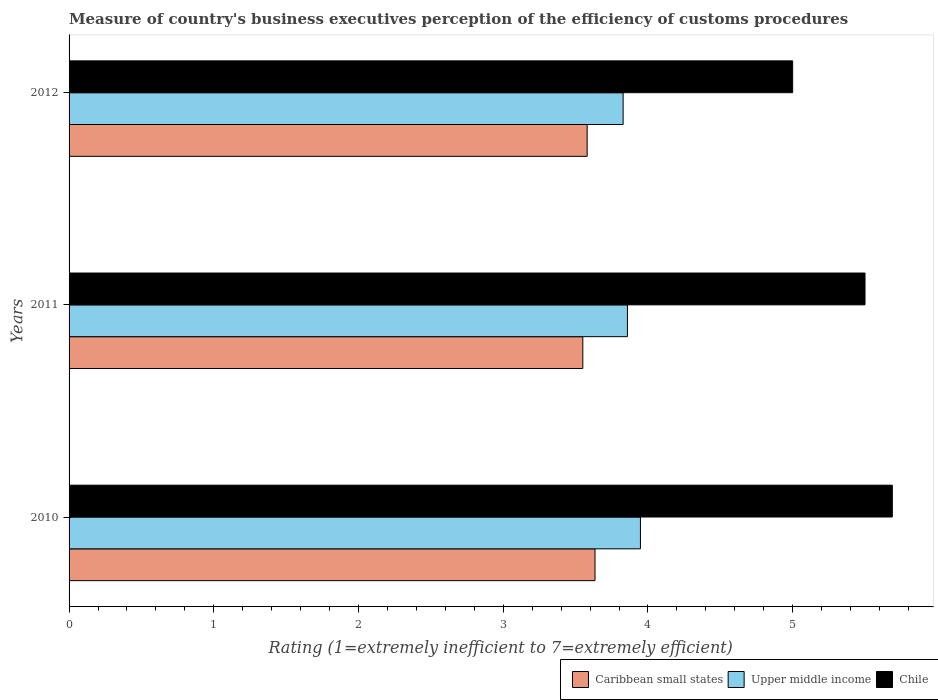Are the number of bars per tick equal to the number of legend labels?
Your answer should be compact. Yes. Are the number of bars on each tick of the Y-axis equal?
Your answer should be very brief. Yes. How many bars are there on the 1st tick from the bottom?
Offer a terse response. 3. Across all years, what is the maximum rating of the efficiency of customs procedure in Chile?
Ensure brevity in your answer.  5.69. Across all years, what is the minimum rating of the efficiency of customs procedure in Upper middle income?
Make the answer very short. 3.83. In which year was the rating of the efficiency of customs procedure in Chile maximum?
Provide a succinct answer. 2010. In which year was the rating of the efficiency of customs procedure in Upper middle income minimum?
Provide a succinct answer. 2012. What is the total rating of the efficiency of customs procedure in Caribbean small states in the graph?
Make the answer very short. 10.76. What is the difference between the rating of the efficiency of customs procedure in Chile in 2010 and that in 2012?
Make the answer very short. 0.69. What is the difference between the rating of the efficiency of customs procedure in Upper middle income in 2010 and the rating of the efficiency of customs procedure in Chile in 2011?
Provide a short and direct response. -1.55. What is the average rating of the efficiency of customs procedure in Upper middle income per year?
Offer a very short reply. 3.88. In the year 2011, what is the difference between the rating of the efficiency of customs procedure in Upper middle income and rating of the efficiency of customs procedure in Caribbean small states?
Give a very brief answer. 0.31. What is the ratio of the rating of the efficiency of customs procedure in Caribbean small states in 2011 to that in 2012?
Your answer should be very brief. 0.99. What is the difference between the highest and the second highest rating of the efficiency of customs procedure in Caribbean small states?
Offer a very short reply. 0.05. What is the difference between the highest and the lowest rating of the efficiency of customs procedure in Chile?
Offer a terse response. 0.69. What does the 2nd bar from the top in 2012 represents?
Your answer should be very brief. Upper middle income. Is it the case that in every year, the sum of the rating of the efficiency of customs procedure in Chile and rating of the efficiency of customs procedure in Caribbean small states is greater than the rating of the efficiency of customs procedure in Upper middle income?
Provide a short and direct response. Yes. How many bars are there?
Keep it short and to the point. 9. Are all the bars in the graph horizontal?
Keep it short and to the point. Yes. How many years are there in the graph?
Make the answer very short. 3. How many legend labels are there?
Offer a very short reply. 3. What is the title of the graph?
Keep it short and to the point. Measure of country's business executives perception of the efficiency of customs procedures. Does "Kyrgyz Republic" appear as one of the legend labels in the graph?
Your answer should be compact. No. What is the label or title of the X-axis?
Ensure brevity in your answer.  Rating (1=extremely inefficient to 7=extremely efficient). What is the label or title of the Y-axis?
Give a very brief answer. Years. What is the Rating (1=extremely inefficient to 7=extremely efficient) in Caribbean small states in 2010?
Offer a very short reply. 3.63. What is the Rating (1=extremely inefficient to 7=extremely efficient) in Upper middle income in 2010?
Keep it short and to the point. 3.95. What is the Rating (1=extremely inefficient to 7=extremely efficient) of Chile in 2010?
Keep it short and to the point. 5.69. What is the Rating (1=extremely inefficient to 7=extremely efficient) of Caribbean small states in 2011?
Provide a succinct answer. 3.55. What is the Rating (1=extremely inefficient to 7=extremely efficient) in Upper middle income in 2011?
Keep it short and to the point. 3.86. What is the Rating (1=extremely inefficient to 7=extremely efficient) of Chile in 2011?
Ensure brevity in your answer.  5.5. What is the Rating (1=extremely inefficient to 7=extremely efficient) in Caribbean small states in 2012?
Provide a short and direct response. 3.58. What is the Rating (1=extremely inefficient to 7=extremely efficient) of Upper middle income in 2012?
Offer a very short reply. 3.83. Across all years, what is the maximum Rating (1=extremely inefficient to 7=extremely efficient) in Caribbean small states?
Provide a short and direct response. 3.63. Across all years, what is the maximum Rating (1=extremely inefficient to 7=extremely efficient) in Upper middle income?
Ensure brevity in your answer.  3.95. Across all years, what is the maximum Rating (1=extremely inefficient to 7=extremely efficient) in Chile?
Make the answer very short. 5.69. Across all years, what is the minimum Rating (1=extremely inefficient to 7=extremely efficient) of Caribbean small states?
Your answer should be very brief. 3.55. Across all years, what is the minimum Rating (1=extremely inefficient to 7=extremely efficient) of Upper middle income?
Your response must be concise. 3.83. Across all years, what is the minimum Rating (1=extremely inefficient to 7=extremely efficient) in Chile?
Offer a terse response. 5. What is the total Rating (1=extremely inefficient to 7=extremely efficient) in Caribbean small states in the graph?
Your answer should be very brief. 10.76. What is the total Rating (1=extremely inefficient to 7=extremely efficient) in Upper middle income in the graph?
Make the answer very short. 11.63. What is the total Rating (1=extremely inefficient to 7=extremely efficient) of Chile in the graph?
Give a very brief answer. 16.19. What is the difference between the Rating (1=extremely inefficient to 7=extremely efficient) of Caribbean small states in 2010 and that in 2011?
Offer a very short reply. 0.08. What is the difference between the Rating (1=extremely inefficient to 7=extremely efficient) of Upper middle income in 2010 and that in 2011?
Keep it short and to the point. 0.09. What is the difference between the Rating (1=extremely inefficient to 7=extremely efficient) in Chile in 2010 and that in 2011?
Make the answer very short. 0.19. What is the difference between the Rating (1=extremely inefficient to 7=extremely efficient) of Caribbean small states in 2010 and that in 2012?
Offer a very short reply. 0.05. What is the difference between the Rating (1=extremely inefficient to 7=extremely efficient) in Upper middle income in 2010 and that in 2012?
Keep it short and to the point. 0.12. What is the difference between the Rating (1=extremely inefficient to 7=extremely efficient) of Chile in 2010 and that in 2012?
Your response must be concise. 0.69. What is the difference between the Rating (1=extremely inefficient to 7=extremely efficient) in Caribbean small states in 2011 and that in 2012?
Provide a succinct answer. -0.03. What is the difference between the Rating (1=extremely inefficient to 7=extremely efficient) in Upper middle income in 2011 and that in 2012?
Offer a terse response. 0.03. What is the difference between the Rating (1=extremely inefficient to 7=extremely efficient) in Caribbean small states in 2010 and the Rating (1=extremely inefficient to 7=extremely efficient) in Upper middle income in 2011?
Ensure brevity in your answer.  -0.22. What is the difference between the Rating (1=extremely inefficient to 7=extremely efficient) in Caribbean small states in 2010 and the Rating (1=extremely inefficient to 7=extremely efficient) in Chile in 2011?
Ensure brevity in your answer.  -1.87. What is the difference between the Rating (1=extremely inefficient to 7=extremely efficient) in Upper middle income in 2010 and the Rating (1=extremely inefficient to 7=extremely efficient) in Chile in 2011?
Give a very brief answer. -1.55. What is the difference between the Rating (1=extremely inefficient to 7=extremely efficient) in Caribbean small states in 2010 and the Rating (1=extremely inefficient to 7=extremely efficient) in Upper middle income in 2012?
Offer a very short reply. -0.19. What is the difference between the Rating (1=extremely inefficient to 7=extremely efficient) of Caribbean small states in 2010 and the Rating (1=extremely inefficient to 7=extremely efficient) of Chile in 2012?
Offer a terse response. -1.37. What is the difference between the Rating (1=extremely inefficient to 7=extremely efficient) in Upper middle income in 2010 and the Rating (1=extremely inefficient to 7=extremely efficient) in Chile in 2012?
Offer a very short reply. -1.05. What is the difference between the Rating (1=extremely inefficient to 7=extremely efficient) in Caribbean small states in 2011 and the Rating (1=extremely inefficient to 7=extremely efficient) in Upper middle income in 2012?
Offer a terse response. -0.28. What is the difference between the Rating (1=extremely inefficient to 7=extremely efficient) of Caribbean small states in 2011 and the Rating (1=extremely inefficient to 7=extremely efficient) of Chile in 2012?
Give a very brief answer. -1.45. What is the difference between the Rating (1=extremely inefficient to 7=extremely efficient) of Upper middle income in 2011 and the Rating (1=extremely inefficient to 7=extremely efficient) of Chile in 2012?
Ensure brevity in your answer.  -1.14. What is the average Rating (1=extremely inefficient to 7=extremely efficient) of Caribbean small states per year?
Ensure brevity in your answer.  3.59. What is the average Rating (1=extremely inefficient to 7=extremely efficient) in Upper middle income per year?
Give a very brief answer. 3.88. What is the average Rating (1=extremely inefficient to 7=extremely efficient) of Chile per year?
Provide a short and direct response. 5.4. In the year 2010, what is the difference between the Rating (1=extremely inefficient to 7=extremely efficient) in Caribbean small states and Rating (1=extremely inefficient to 7=extremely efficient) in Upper middle income?
Give a very brief answer. -0.31. In the year 2010, what is the difference between the Rating (1=extremely inefficient to 7=extremely efficient) of Caribbean small states and Rating (1=extremely inefficient to 7=extremely efficient) of Chile?
Offer a very short reply. -2.05. In the year 2010, what is the difference between the Rating (1=extremely inefficient to 7=extremely efficient) in Upper middle income and Rating (1=extremely inefficient to 7=extremely efficient) in Chile?
Keep it short and to the point. -1.74. In the year 2011, what is the difference between the Rating (1=extremely inefficient to 7=extremely efficient) of Caribbean small states and Rating (1=extremely inefficient to 7=extremely efficient) of Upper middle income?
Keep it short and to the point. -0.31. In the year 2011, what is the difference between the Rating (1=extremely inefficient to 7=extremely efficient) of Caribbean small states and Rating (1=extremely inefficient to 7=extremely efficient) of Chile?
Keep it short and to the point. -1.95. In the year 2011, what is the difference between the Rating (1=extremely inefficient to 7=extremely efficient) of Upper middle income and Rating (1=extremely inefficient to 7=extremely efficient) of Chile?
Your response must be concise. -1.64. In the year 2012, what is the difference between the Rating (1=extremely inefficient to 7=extremely efficient) of Caribbean small states and Rating (1=extremely inefficient to 7=extremely efficient) of Upper middle income?
Keep it short and to the point. -0.25. In the year 2012, what is the difference between the Rating (1=extremely inefficient to 7=extremely efficient) in Caribbean small states and Rating (1=extremely inefficient to 7=extremely efficient) in Chile?
Keep it short and to the point. -1.42. In the year 2012, what is the difference between the Rating (1=extremely inefficient to 7=extremely efficient) of Upper middle income and Rating (1=extremely inefficient to 7=extremely efficient) of Chile?
Offer a terse response. -1.17. What is the ratio of the Rating (1=extremely inefficient to 7=extremely efficient) of Caribbean small states in 2010 to that in 2011?
Your answer should be very brief. 1.02. What is the ratio of the Rating (1=extremely inefficient to 7=extremely efficient) of Upper middle income in 2010 to that in 2011?
Provide a succinct answer. 1.02. What is the ratio of the Rating (1=extremely inefficient to 7=extremely efficient) of Chile in 2010 to that in 2011?
Give a very brief answer. 1.03. What is the ratio of the Rating (1=extremely inefficient to 7=extremely efficient) of Caribbean small states in 2010 to that in 2012?
Offer a very short reply. 1.02. What is the ratio of the Rating (1=extremely inefficient to 7=extremely efficient) of Upper middle income in 2010 to that in 2012?
Ensure brevity in your answer.  1.03. What is the ratio of the Rating (1=extremely inefficient to 7=extremely efficient) in Chile in 2010 to that in 2012?
Provide a succinct answer. 1.14. What is the ratio of the Rating (1=extremely inefficient to 7=extremely efficient) in Chile in 2011 to that in 2012?
Ensure brevity in your answer.  1.1. What is the difference between the highest and the second highest Rating (1=extremely inefficient to 7=extremely efficient) in Caribbean small states?
Give a very brief answer. 0.05. What is the difference between the highest and the second highest Rating (1=extremely inefficient to 7=extremely efficient) in Upper middle income?
Provide a short and direct response. 0.09. What is the difference between the highest and the second highest Rating (1=extremely inefficient to 7=extremely efficient) in Chile?
Your answer should be compact. 0.19. What is the difference between the highest and the lowest Rating (1=extremely inefficient to 7=extremely efficient) in Caribbean small states?
Keep it short and to the point. 0.08. What is the difference between the highest and the lowest Rating (1=extremely inefficient to 7=extremely efficient) of Upper middle income?
Keep it short and to the point. 0.12. What is the difference between the highest and the lowest Rating (1=extremely inefficient to 7=extremely efficient) in Chile?
Offer a very short reply. 0.69. 